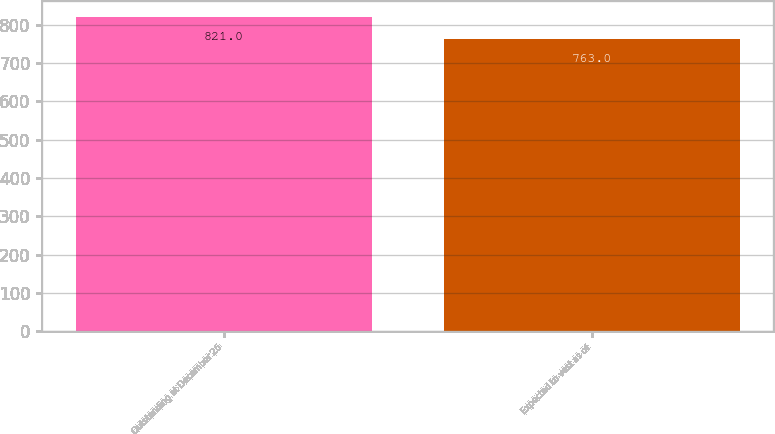Convert chart. <chart><loc_0><loc_0><loc_500><loc_500><bar_chart><fcel>Outstanding at December 26<fcel>Expected to vest as of<nl><fcel>821<fcel>763<nl></chart> 